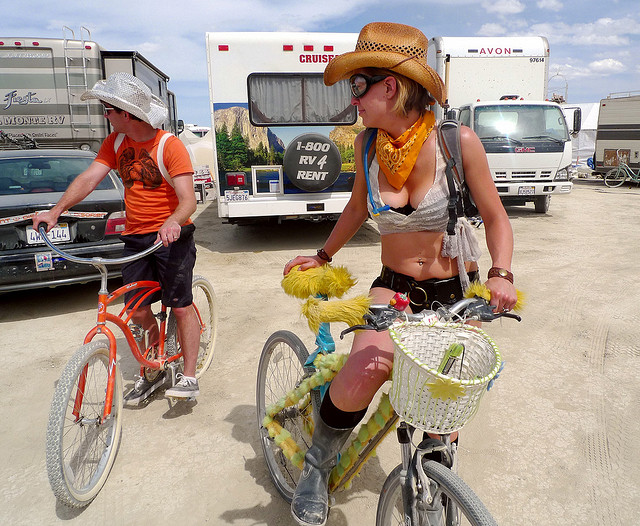Read all the text in this image. MONTE Fiesta 5JF6816 AVON CRUISE RENT 4 RV I-BOO 